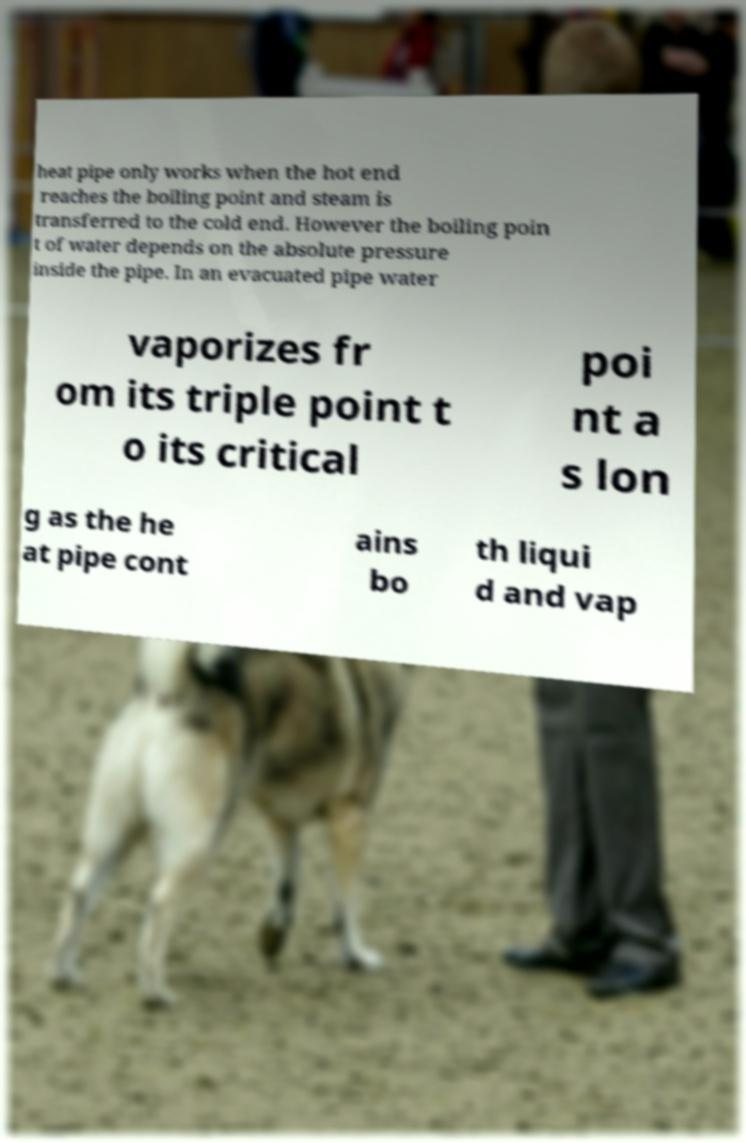Could you extract and type out the text from this image? heat pipe only works when the hot end reaches the boiling point and steam is transferred to the cold end. However the boiling poin t of water depends on the absolute pressure inside the pipe. In an evacuated pipe water vaporizes fr om its triple point t o its critical poi nt a s lon g as the he at pipe cont ains bo th liqui d and vap 